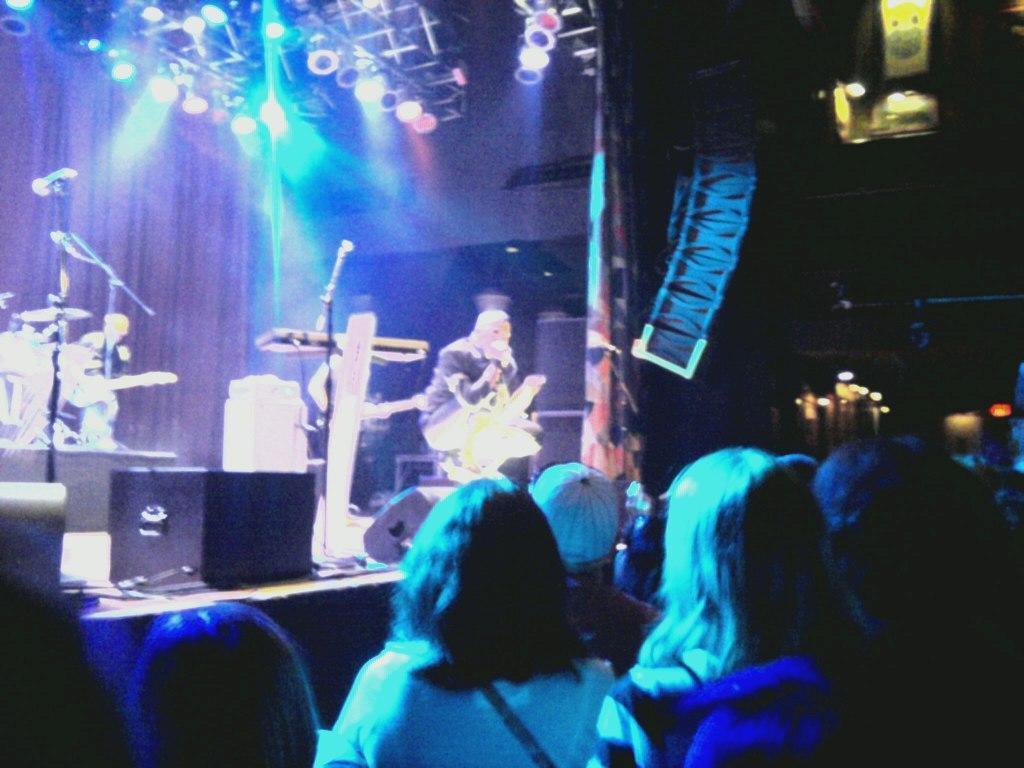Please provide a concise description of this image. In the foreground of this image, there are persons. In the background, on the stage, there is a person, few mics, musical instruments, light on the top and the dark background. 